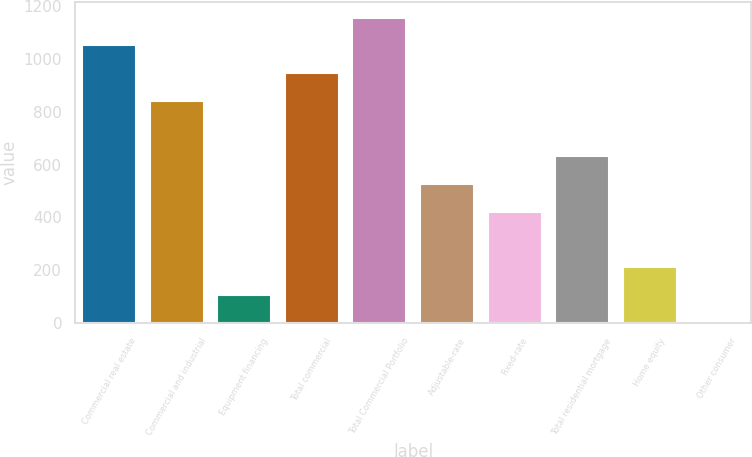Convert chart. <chart><loc_0><loc_0><loc_500><loc_500><bar_chart><fcel>Commercial real estate<fcel>Commercial and industrial<fcel>Equipment financing<fcel>Total commercial<fcel>Total Commercial Portfolio<fcel>Adjustable-rate<fcel>Fixed-rate<fcel>Total residential mortgage<fcel>Home equity<fcel>Other consumer<nl><fcel>1050.9<fcel>840.96<fcel>106.17<fcel>945.93<fcel>1155.87<fcel>526.05<fcel>421.08<fcel>631.02<fcel>211.14<fcel>1.2<nl></chart> 